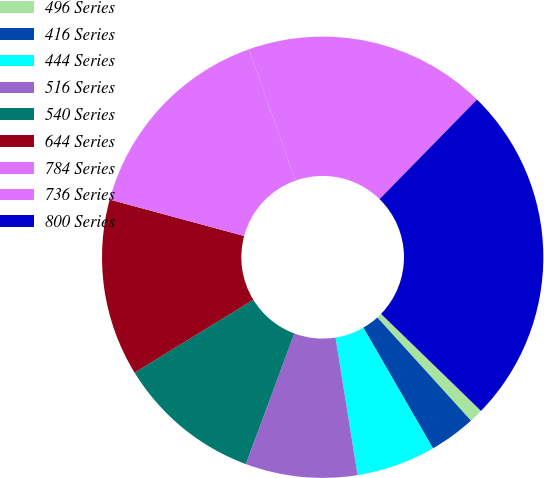Convert chart to OTSL. <chart><loc_0><loc_0><loc_500><loc_500><pie_chart><fcel>496 Series<fcel>416 Series<fcel>444 Series<fcel>516 Series<fcel>540 Series<fcel>644 Series<fcel>784 Series<fcel>736 Series<fcel>800 Series<nl><fcel>1.01%<fcel>3.4%<fcel>5.8%<fcel>8.19%<fcel>10.58%<fcel>12.97%<fcel>15.36%<fcel>17.76%<fcel>24.93%<nl></chart> 